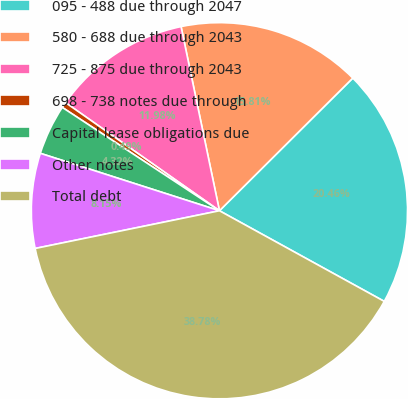Convert chart. <chart><loc_0><loc_0><loc_500><loc_500><pie_chart><fcel>095 - 488 due through 2047<fcel>580 - 688 due through 2043<fcel>725 - 875 due through 2043<fcel>698 - 738 notes due through<fcel>Capital lease obligations due<fcel>Other notes<fcel>Total debt<nl><fcel>20.46%<fcel>15.81%<fcel>11.98%<fcel>0.49%<fcel>4.32%<fcel>8.15%<fcel>38.78%<nl></chart> 